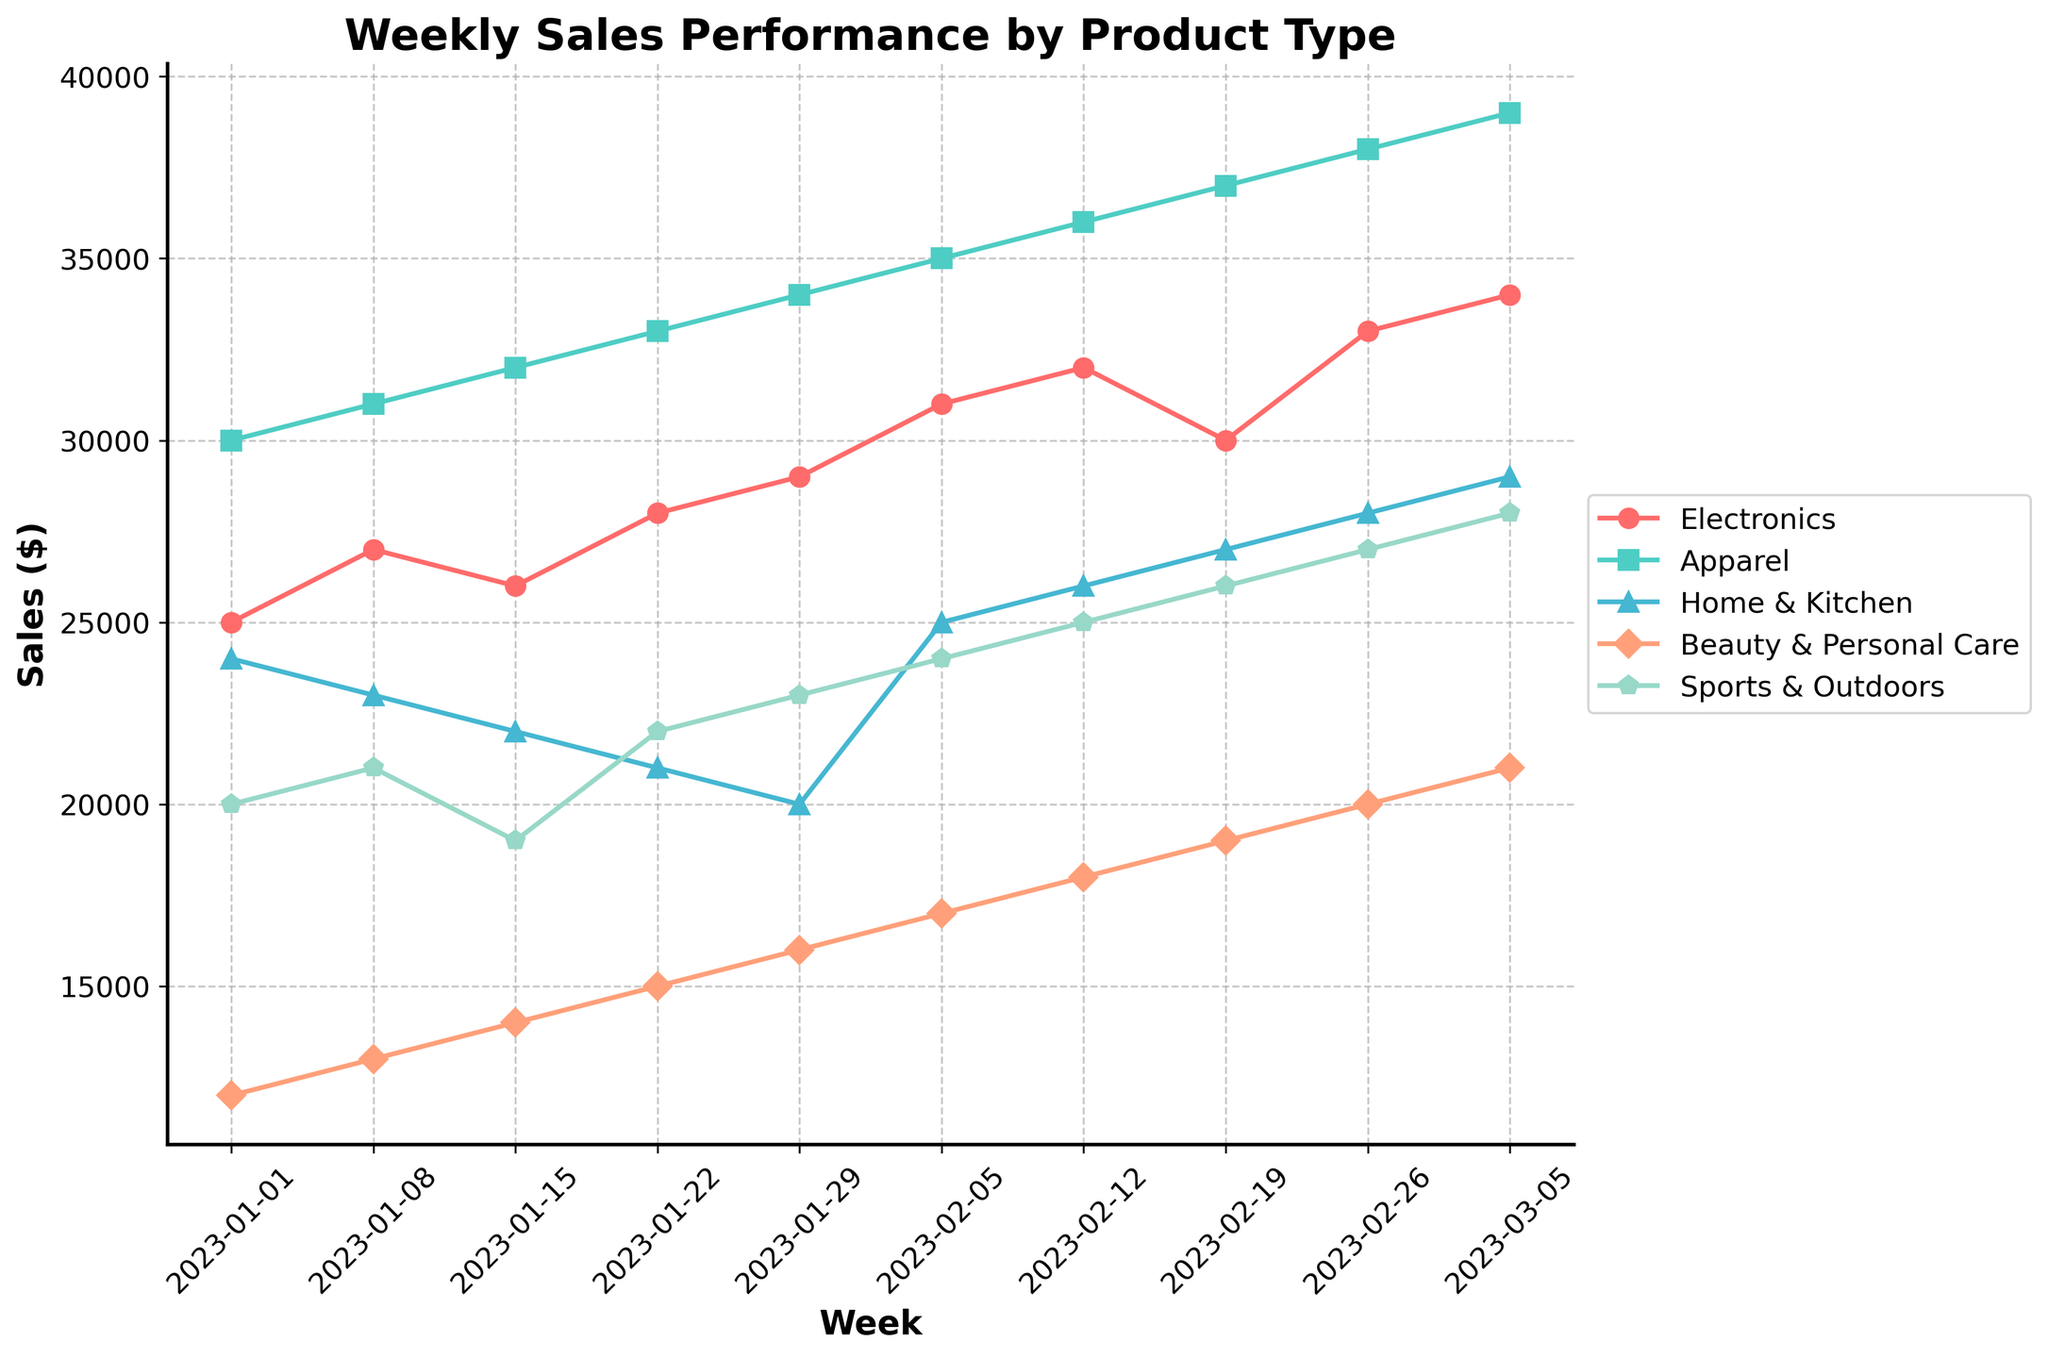how many weeks of data are shown in the figure? To find the number of weeks, count the unique entries on the x-axis. The data table shows 10 weeks.
Answer: 10 what's the title of the figure? The title is displayed at the top of the figure. It's labeled "Weekly Sales Performance by Product Type".
Answer: Weekly Sales Performance by Product Type which product type has the highest sales on the week of 2023-02-26? Look at the values for each line on the date 2023-02-26 and identify the highest point on the y-axis. Apparel shows the highest sales.
Answer: Apparel what is the color of the line representing "Sports & Outdoors"? Identify the line legend that matches "Sports & Outdoors" and observe its color. The line is colored light green.
Answer: light green During which week did "Home & Kitchen" experience its lowest sales? Find the lowest point on the "Home & Kitchen" line and note the corresponding week on the x-axis. The lowest sales occur on 2023-01-29.
Answer: 2023-01-29 what is the average sales value for "Beauty & Personal Care" across all weeks? Sum the values for "Beauty & Personal Care" for each week and divide by the number of weeks: (12000 + 13000 + 14000 + 15000 + 16000 + 17000 + 18000 + 19000 + 20000 + 21000) / 10 = 15500.
Answer: 15500 how do the sales of "Electronics" compare to "Home & Kitchen" on 2023-02-05? Check the data points for "Electronics" and "Home & Kitchen" on 2023-02-05. Electronics: 31000, Home & Kitchen: 25000. Electronics has higher sales.
Answer: Electronics has higher sales which product type shows the most consistent sales trend over the weeks? Identify the line with the least fluctuations (smallest variance). "Apparel" shows the most consistent trend with a steady increase.
Answer: Apparel what is the total sales of "Sports & Outdoors" for the first three weeks? Sum the sales values of "Sports & Outdoors" for the first three weeks: 20000 + 21000 + 19000 = 60000.
Answer: 60000 